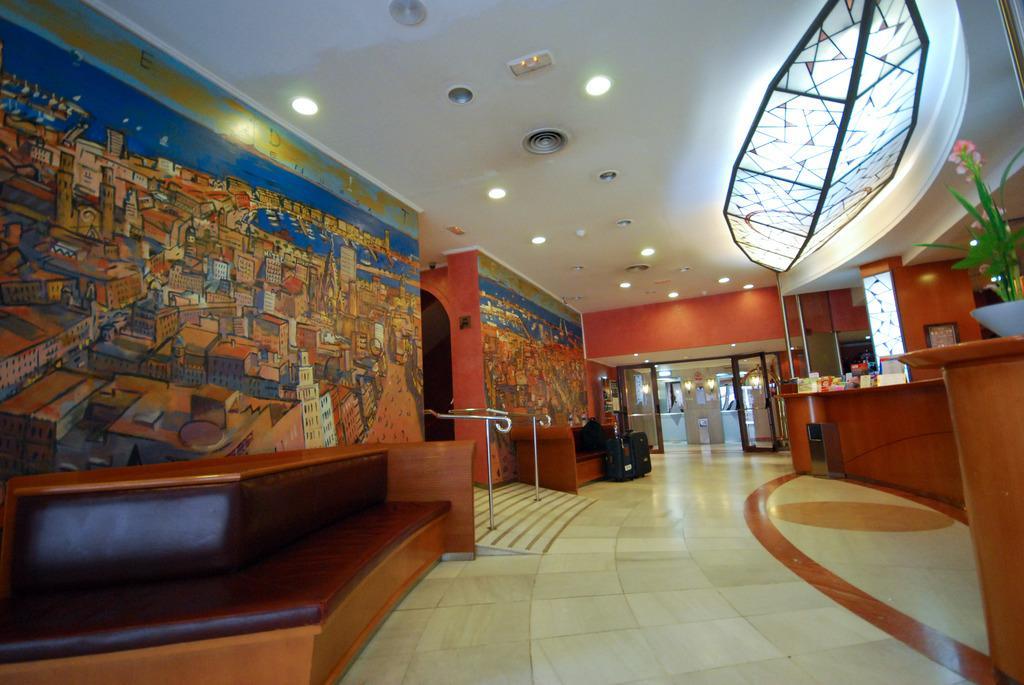Could you give a brief overview of what you see in this image? In this image there are sofas. On top of the sofa there is a bag. In front of the sofa there are bags. On the right side of the image there is a flower pot and a few other objects on the table. There is a photo frame on the wall. There is a painting on the wall. There is a railing. On top of the image there are lights. At the bottom of the image there is a floor. In the background of the image there is a glass door. 